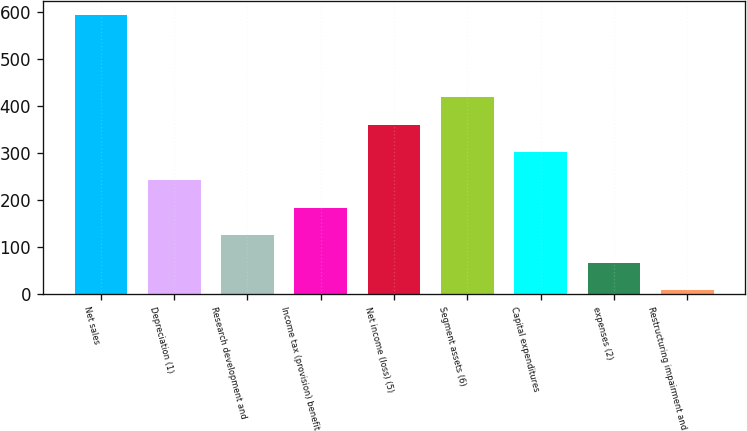<chart> <loc_0><loc_0><loc_500><loc_500><bar_chart><fcel>Net sales<fcel>Depreciation (1)<fcel>Research development and<fcel>Income tax (provision) benefit<fcel>Net income (loss) (5)<fcel>Segment assets (6)<fcel>Capital expenditures<fcel>expenses (2)<fcel>Restructuring impairment and<nl><fcel>595<fcel>242.8<fcel>125.4<fcel>184.1<fcel>360.2<fcel>418.9<fcel>301.5<fcel>66.7<fcel>8<nl></chart> 